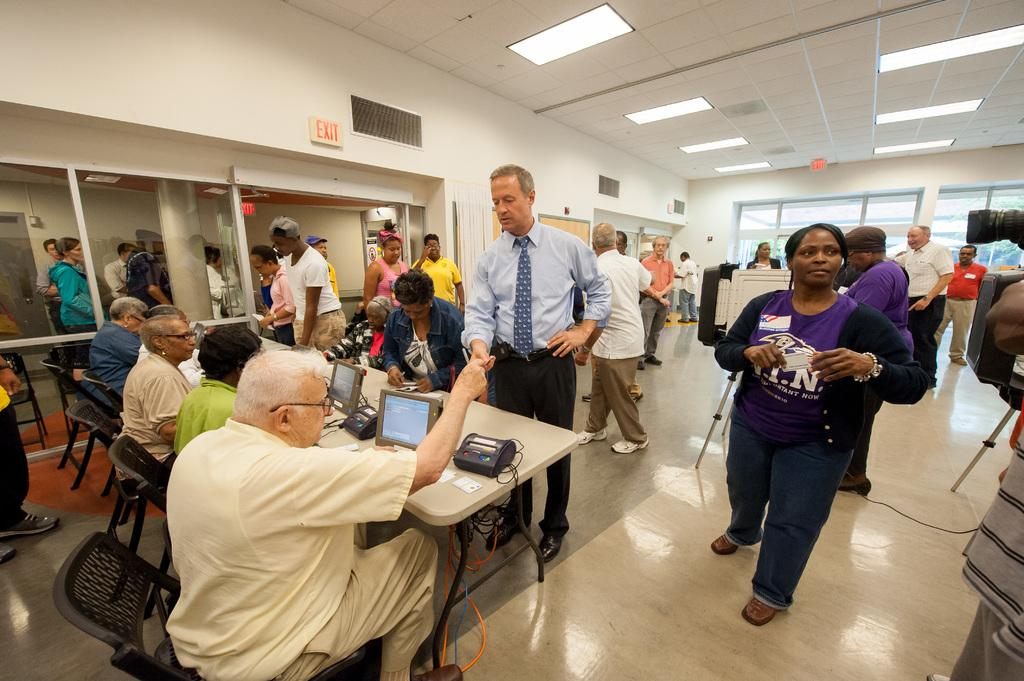<image>
Relay a brief, clear account of the picture shown. a person with the letter N on their shirt 